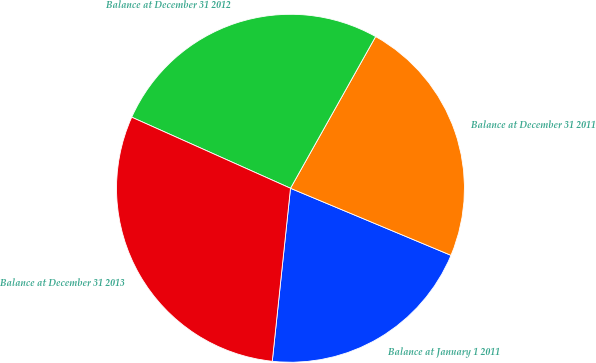Convert chart to OTSL. <chart><loc_0><loc_0><loc_500><loc_500><pie_chart><fcel>Balance at January 1 2011<fcel>Balance at December 31 2011<fcel>Balance at December 31 2012<fcel>Balance at December 31 2013<nl><fcel>20.37%<fcel>23.16%<fcel>26.44%<fcel>30.03%<nl></chart> 